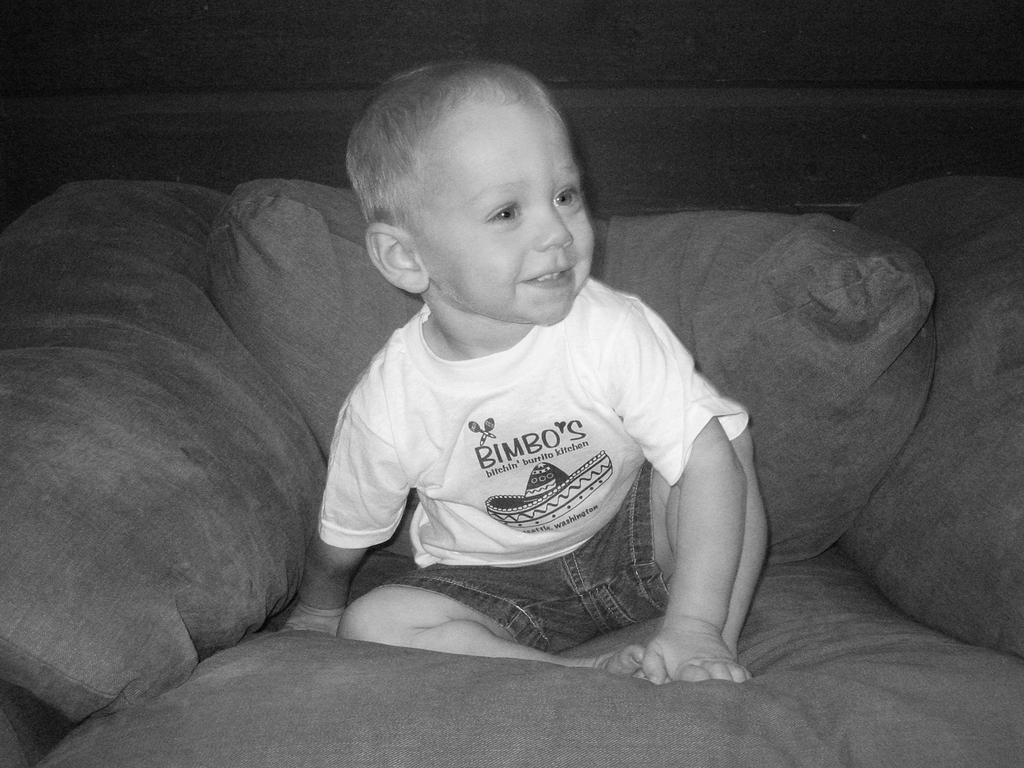What is the color scheme of the image? The image is black and white. Who is present in the image? There is a kid in the image. What is the kid doing in the image? The kid is sitting on a couch. Are there any additional objects in the image? Yes, there are pillows in the image. What type of dock can be seen in the image? A: There is no dock present in the image. What riddle is the kid trying to solve in the image? There is no riddle present in the image; the kid is simply sitting on a couch. 